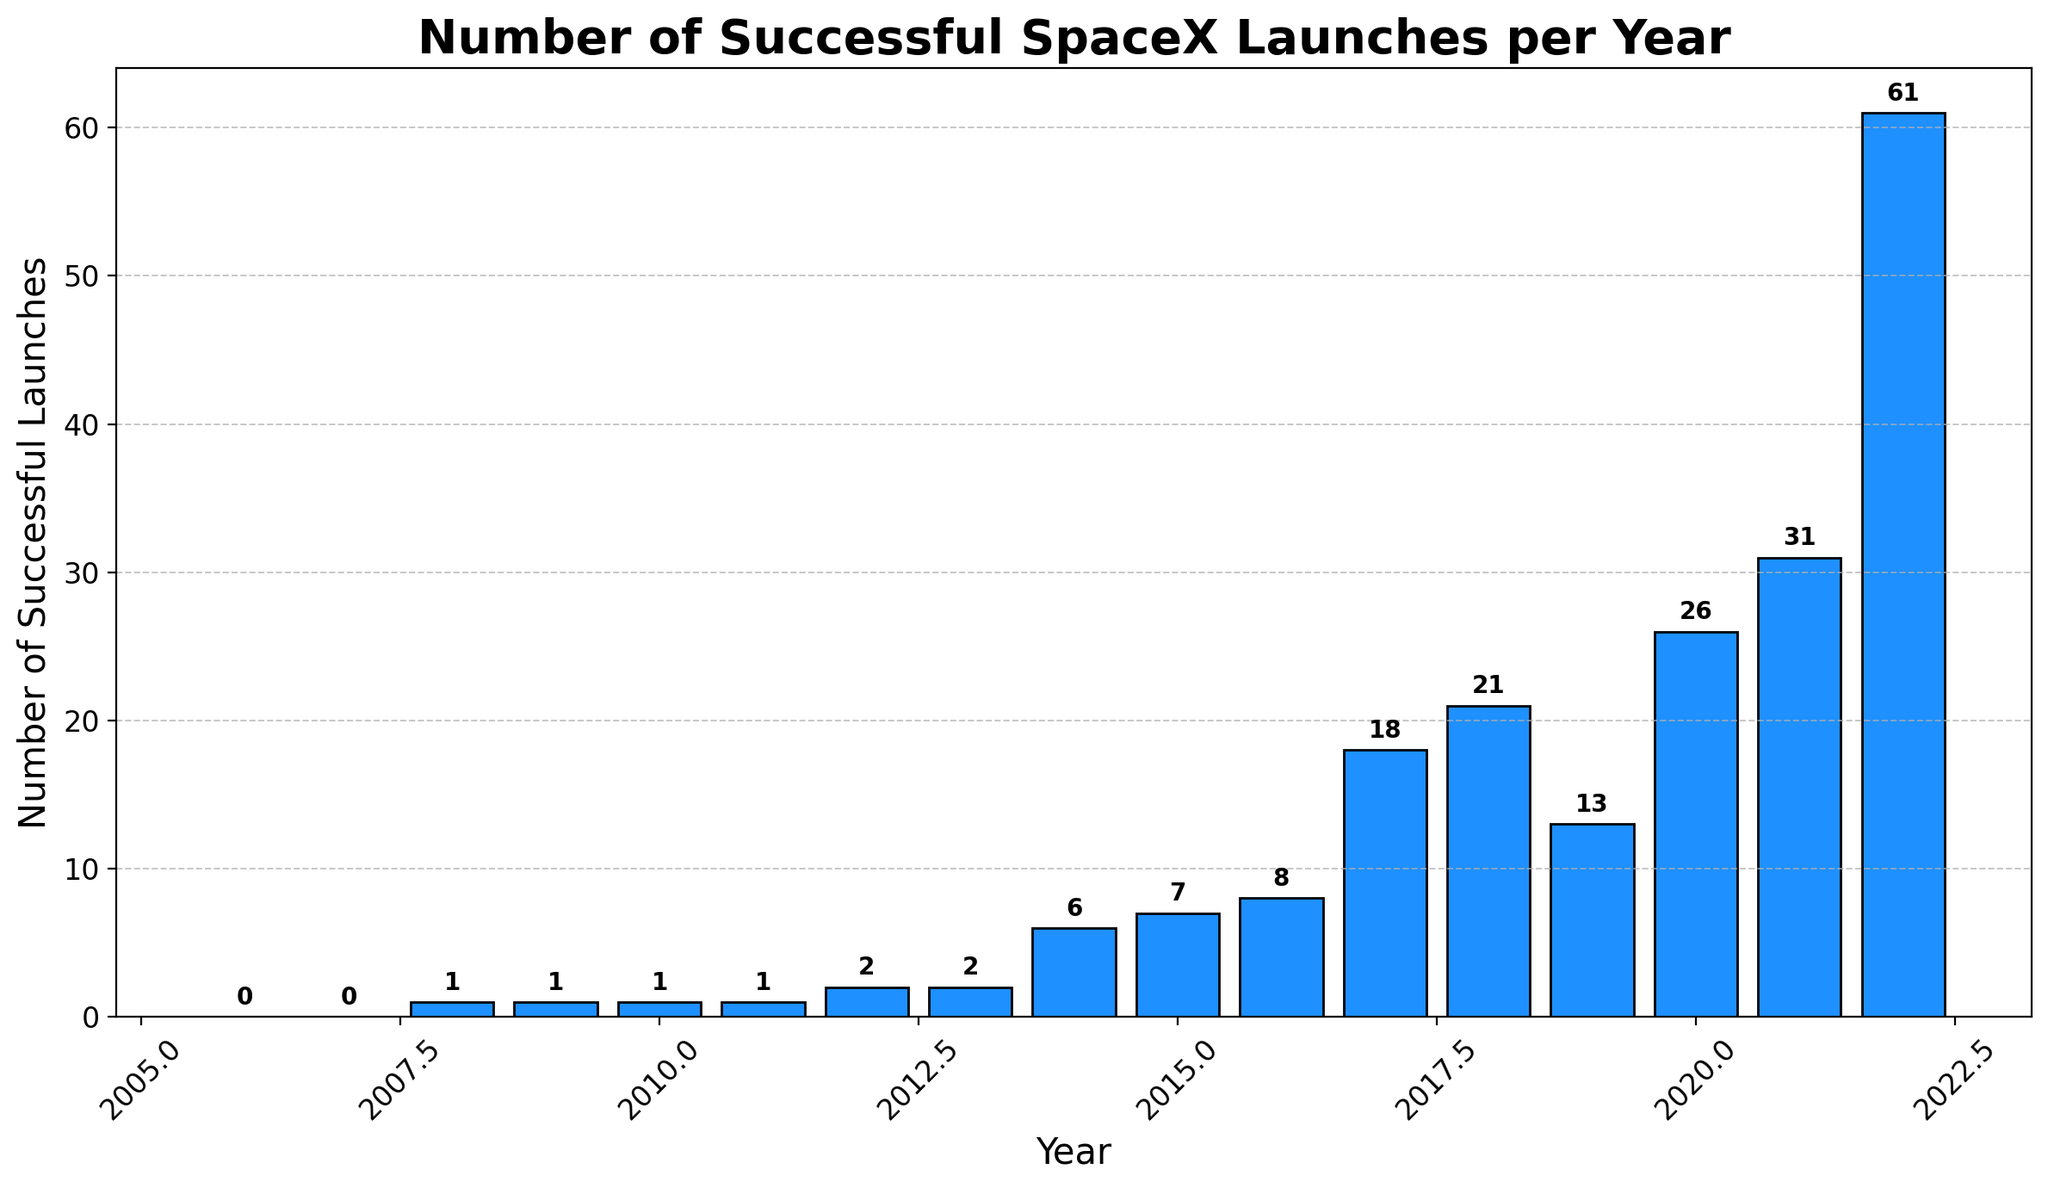What's the total number of successful SpaceX launches from 2006 to 2012? Sum the number of successful launches for each year from 2006 to 2012: 0 (2006) + 0 (2007) + 1 (2008) + 1 (2009) + 1 (2010) + 1 (2011) + 2 (2012) = 6
Answer: 6 Which year saw the highest number of successful SpaceX launches? Compare the number of successful launches each year. The year with the highest number is 2022 with 61 successful launches
Answer: 2022 How many more successful launches were there in 2022 compared to 2021? Subtract the number of successful launches in 2021 from that in 2022: 61 (2022) - 31 (2021) = 30
Answer: 30 What is the average number of successful SpaceX launches per year from 2015 to 2020? Calculate the sum of successful launches from 2015 to 2020 and then divide by the number of years: (7 + 8 + 18 + 21 + 13 + 26) / 6 = 93 / 6 = 15.5
Answer: 15.5 Which year had the lowest number of successful SpaceX launches? Compare the number of successful launches each year. Both 2006 and 2007 had the lowest, with 0 successful launches
Answer: 2006, 2007 What is the difference in the number of successful launches between 2018 and 2019? Subtract the number of successful launches in 2019 from that in 2018: 21 (2018) - 13 (2019) = 8
Answer: 8 How many years had more than 20 successful SpaceX launches? Count the number of years where the number of successful launches exceeds 20. These years are 2018 (21), 2020 (26), 2021 (31), and 2022 (61), making it 4 years
Answer: 4 Describe the trend in the number of successful SpaceX launches from 2006 to 2022. The number of successful SpaceX launches generally increases over time, starting from 0 launches in 2006 and reaching a peak of 61 launches in 2022, with significant growth especially from 2017 onwards
Answer: Increasing trend By how much did the number of successful launches increase between 2014 and 2016? Subtract the number of successful launches in 2014 from that in 2016: 8 (2016) - 6 (2014) = 2
Answer: 2 